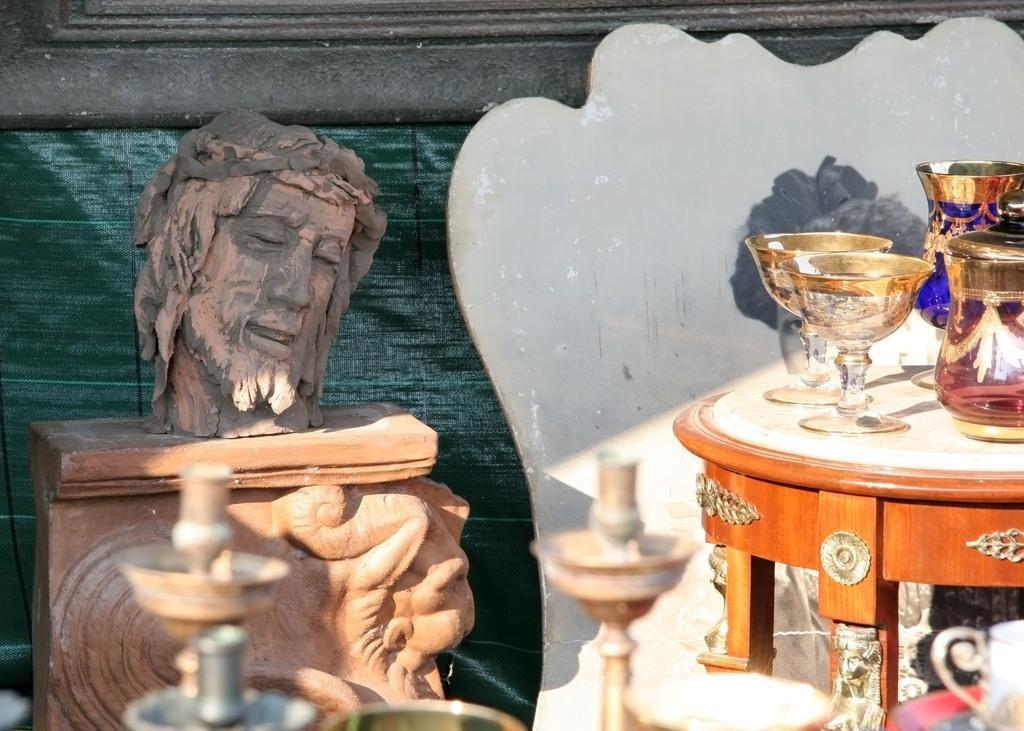Can you describe this image briefly? In this picture we can see a sculpture couple of glasses, jugs on the table. 